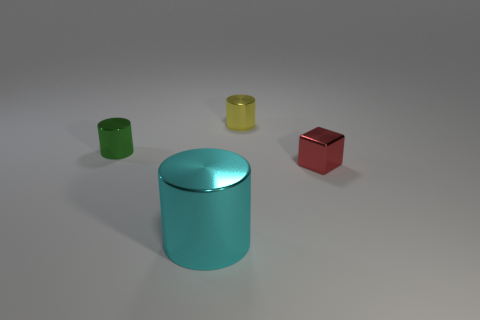Subtract all large shiny cylinders. How many cylinders are left? 2 Subtract all yellow cylinders. How many cylinders are left? 2 Subtract all cubes. How many objects are left? 3 Subtract 3 cylinders. How many cylinders are left? 0 Subtract all gray balls. How many yellow cylinders are left? 1 Subtract all big cyan shiny cylinders. Subtract all big cyan cubes. How many objects are left? 3 Add 2 red metal cubes. How many red metal cubes are left? 3 Add 3 large green shiny cylinders. How many large green shiny cylinders exist? 3 Add 2 tiny brown rubber cylinders. How many objects exist? 6 Subtract 0 red cylinders. How many objects are left? 4 